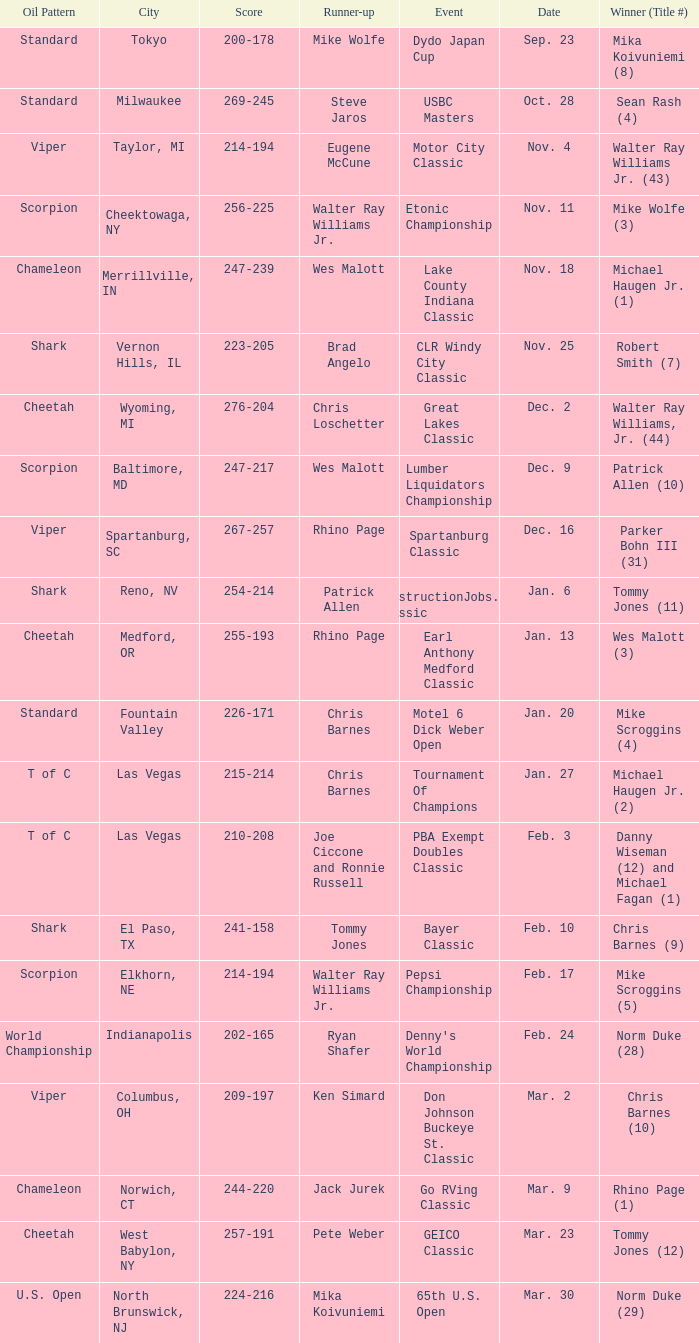Name the Event which has a Score of 209-197? Don Johnson Buckeye St. Classic. 